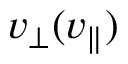<formula> <loc_0><loc_0><loc_500><loc_500>v _ { \perp } ( v _ { \| } )</formula> 